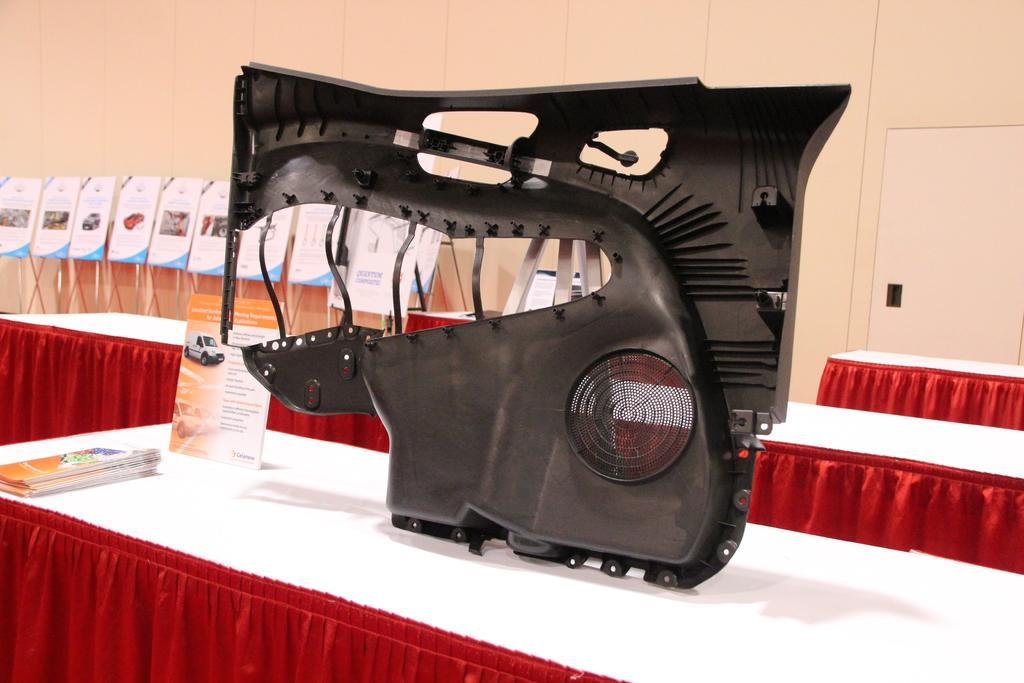Describe this image in one or two sentences. This image is taken indoors. In the background there is a wall and there are many boards with text and a few images on them. There are a few tables with tablecloths. At the bottom of the image there is a table with a tablecloth, a few books and a board with a text on it. In the middle of the image there is a part of a vehicle on the table. 